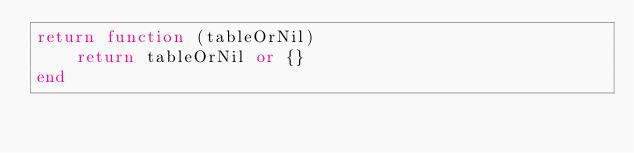Convert code to text. <code><loc_0><loc_0><loc_500><loc_500><_Lua_>return function (tableOrNil)
    return tableOrNil or {}
end</code> 